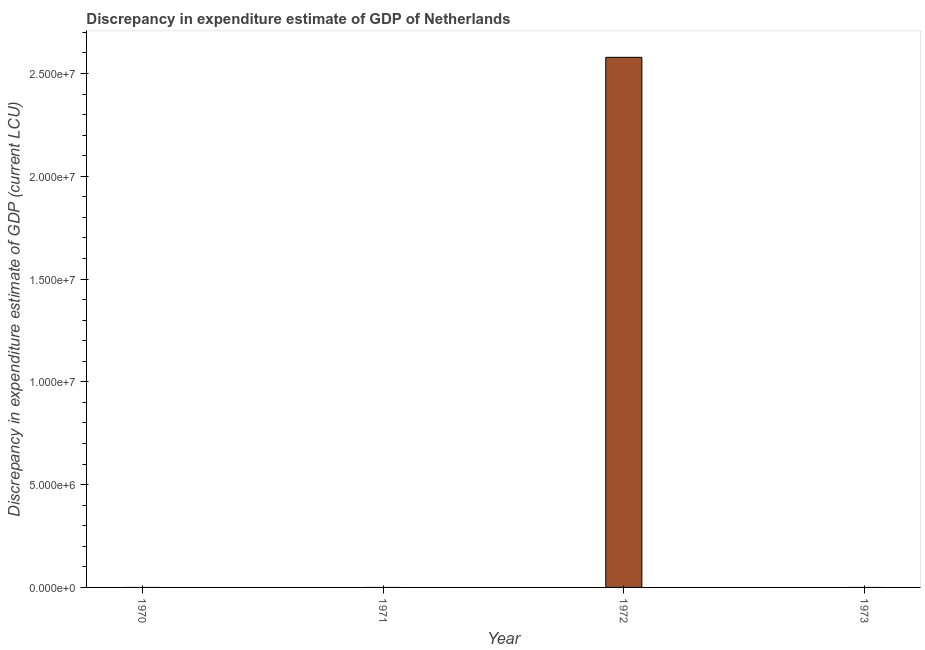Does the graph contain grids?
Ensure brevity in your answer.  No. What is the title of the graph?
Provide a short and direct response. Discrepancy in expenditure estimate of GDP of Netherlands. What is the label or title of the Y-axis?
Give a very brief answer. Discrepancy in expenditure estimate of GDP (current LCU). What is the discrepancy in expenditure estimate of gdp in 1970?
Ensure brevity in your answer.  0. Across all years, what is the maximum discrepancy in expenditure estimate of gdp?
Offer a terse response. 2.58e+07. Across all years, what is the minimum discrepancy in expenditure estimate of gdp?
Your answer should be very brief. 0. In which year was the discrepancy in expenditure estimate of gdp maximum?
Keep it short and to the point. 1972. What is the sum of the discrepancy in expenditure estimate of gdp?
Your response must be concise. 2.58e+07. What is the average discrepancy in expenditure estimate of gdp per year?
Your response must be concise. 6.45e+06. What is the difference between the highest and the lowest discrepancy in expenditure estimate of gdp?
Keep it short and to the point. 2.58e+07. How many bars are there?
Provide a succinct answer. 1. Are all the bars in the graph horizontal?
Make the answer very short. No. How many years are there in the graph?
Offer a very short reply. 4. What is the Discrepancy in expenditure estimate of GDP (current LCU) in 1972?
Provide a short and direct response. 2.58e+07. What is the Discrepancy in expenditure estimate of GDP (current LCU) of 1973?
Ensure brevity in your answer.  0. 